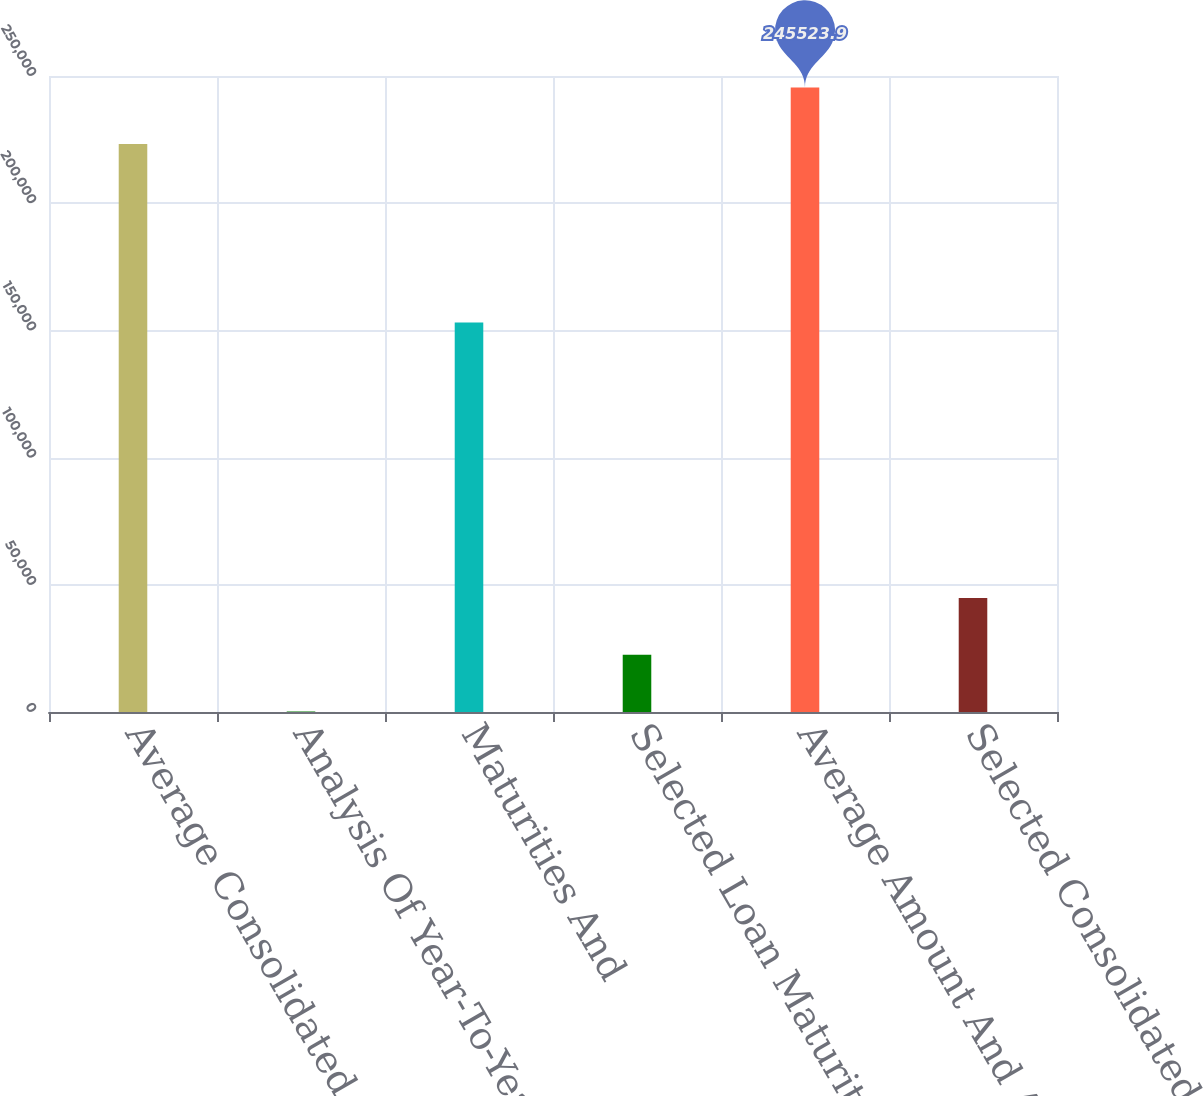Convert chart. <chart><loc_0><loc_0><loc_500><loc_500><bar_chart><fcel>Average Consolidated Balance<fcel>Analysis Of Year-To-Year<fcel>Maturities And<fcel>Selected Loan Maturities And<fcel>Average Amount And Average<fcel>Selected Consolidated<nl><fcel>223224<fcel>225<fcel>153154<fcel>22524.9<fcel>245524<fcel>44824.8<nl></chart> 